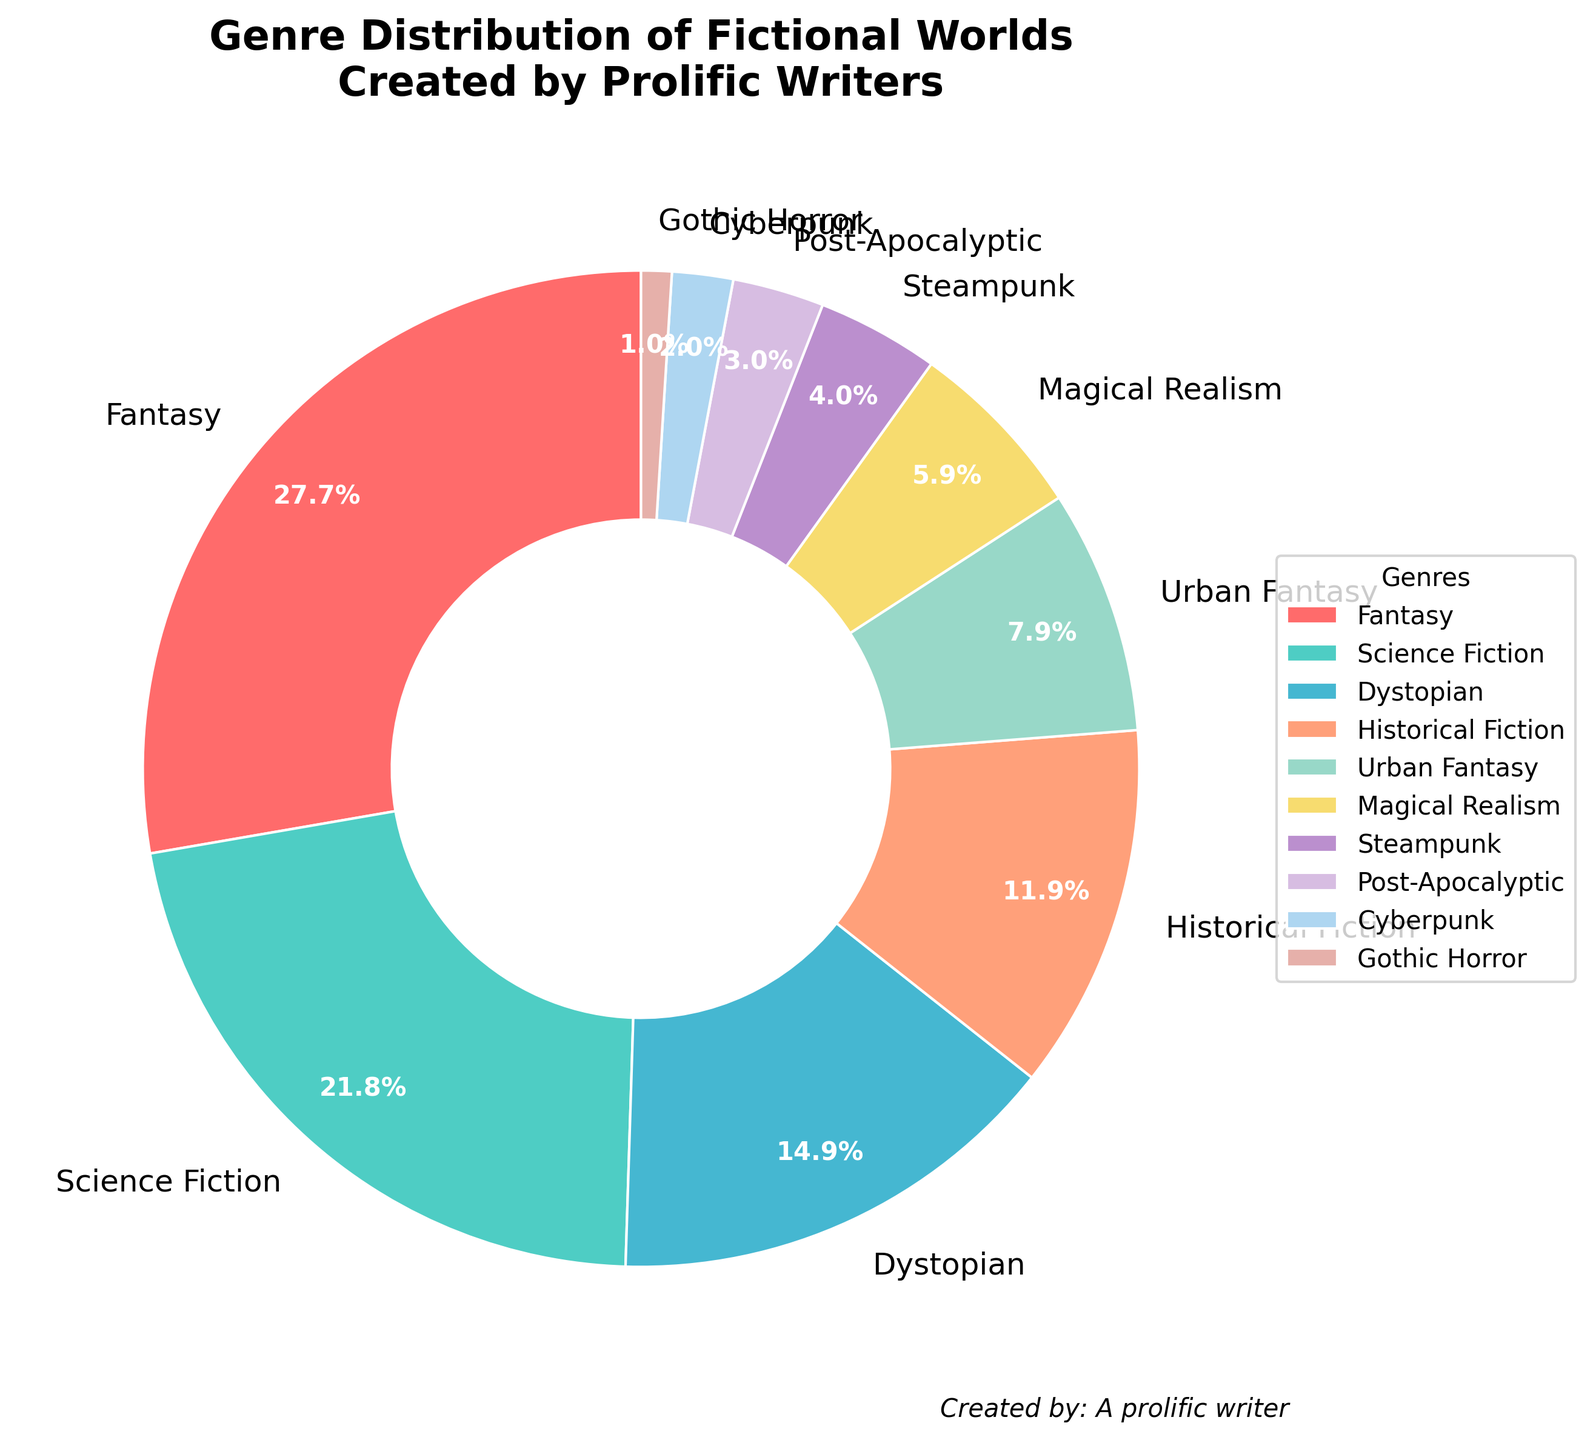What genre has the highest percentage of fictional worlds created by prolific writers? The highest percentage section on the pie chart is the 'Fantasy' slice, visibly the largest. The legend confirms that Fantasy has the largest slice at 28%.
Answer: Fantasy What is the combined percentage of Science Fiction and Steampunk genres? Referring to the legend, Science Fiction is 22% and Steampunk is 4%. Adding these together, 22% + 4% = 26%.
Answer: 26% Which genre has a smaller percentage: Urban Fantasy or Cyberpunk? By looking at the slices and the legend, Urban Fantasy is 8% and Cyberpunk is 2%. Comparing these two, Cyberpunk is smaller.
Answer: Cyberpunk How much more percentage does Historical Fiction have than Post-Apocalyptic? From the legend, Historical Fiction is 12% and Post-Apocalyptic is 3%. Subtracting these values, 12% - 3% = 9%.
Answer: 9% What is the total percentage of genres that are below 10%? Adding the percentages for Urban Fantasy (8%), Magical Realism (6%), Steampunk (4%), Post-Apocalyptic (3%), Cyberpunk (2%), and Gothic Horror (1%), we get 8% + 6% + 4% + 3% + 2% + 1% = 24%.
Answer: 24% How does the percentage of Dystopian worlds compare to Magical Realism worlds? Dystopian has a percentage of 15%, whereas Magical Realism has 6%. Dystopian is more than double Magical Realism.
Answer: Dystopian is greater Are there more Science Fiction or Fantasy worlds, and by what percentage difference? Science Fiction accounts for 22% and Fantasy for 28%. The difference is 28% - 22% = 6%.
Answer: Fantasy by 6% 